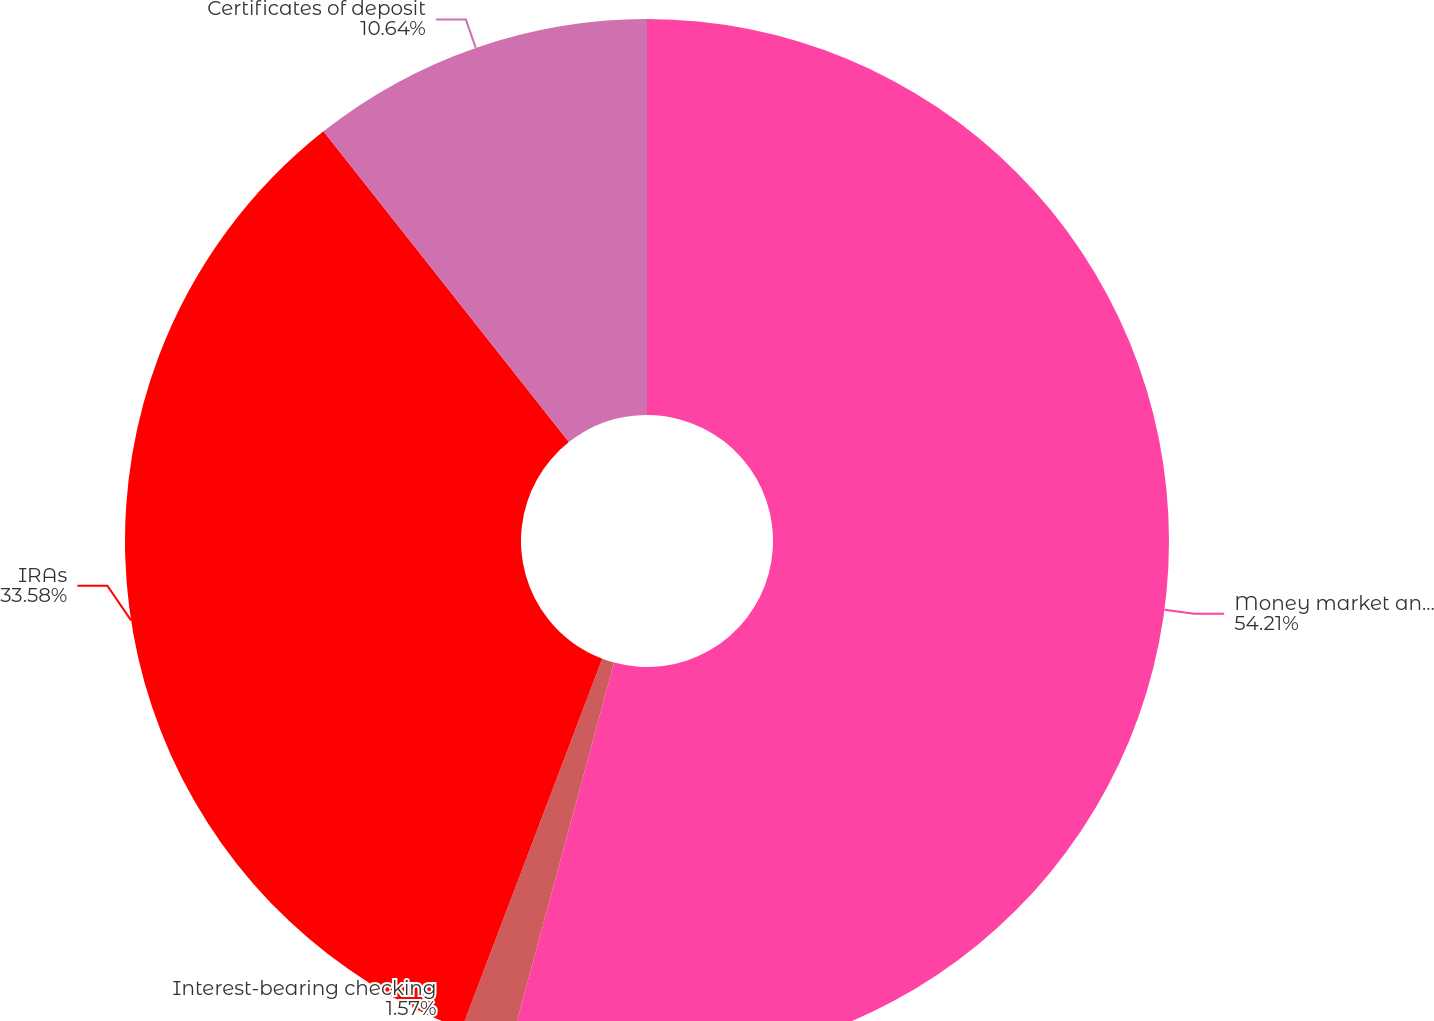Convert chart. <chart><loc_0><loc_0><loc_500><loc_500><pie_chart><fcel>Money market and savings<fcel>Interest-bearing checking<fcel>IRAs<fcel>Certificates of deposit<nl><fcel>54.21%<fcel>1.57%<fcel>33.58%<fcel>10.64%<nl></chart> 